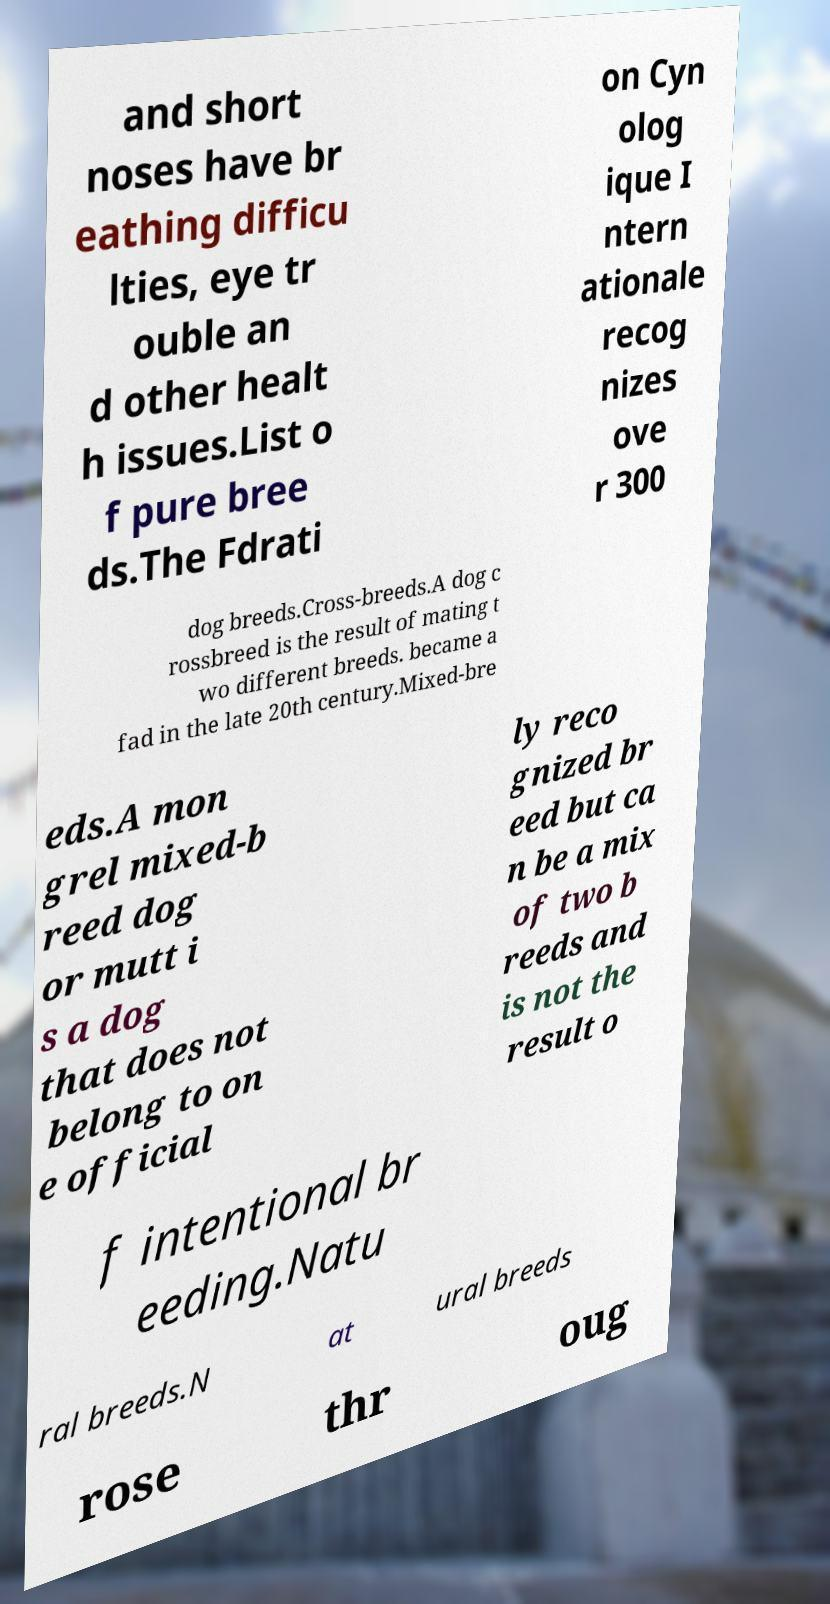Can you accurately transcribe the text from the provided image for me? and short noses have br eathing difficu lties, eye tr ouble an d other healt h issues.List o f pure bree ds.The Fdrati on Cyn olog ique I ntern ationale recog nizes ove r 300 dog breeds.Cross-breeds.A dog c rossbreed is the result of mating t wo different breeds. became a fad in the late 20th century.Mixed-bre eds.A mon grel mixed-b reed dog or mutt i s a dog that does not belong to on e official ly reco gnized br eed but ca n be a mix of two b reeds and is not the result o f intentional br eeding.Natu ral breeds.N at ural breeds rose thr oug 